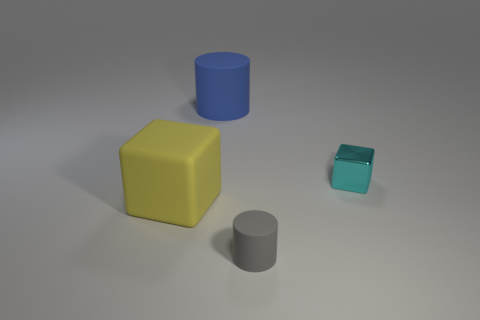What number of tiny metallic objects are the same shape as the large yellow thing?
Provide a short and direct response. 1. What is the shape of the cyan metallic thing that is the same size as the gray rubber cylinder?
Your answer should be very brief. Cube. How many gray objects are cylinders or big things?
Ensure brevity in your answer.  1. Does the small object behind the gray cylinder have the same shape as the rubber object that is right of the blue thing?
Keep it short and to the point. No. What number of other objects are there of the same material as the gray cylinder?
Provide a succinct answer. 2. Are there any cubes right of the cylinder that is behind the large matte thing in front of the big blue cylinder?
Keep it short and to the point. Yes. Does the tiny cyan object have the same material as the small cylinder?
Offer a terse response. No. Is there anything else that has the same shape as the small gray object?
Offer a very short reply. Yes. There is a cube on the right side of the rubber cylinder that is behind the shiny block; what is it made of?
Your response must be concise. Metal. There is a cylinder that is behind the yellow thing; how big is it?
Make the answer very short. Large. 